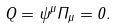<formula> <loc_0><loc_0><loc_500><loc_500>Q = \psi ^ { \mu } \Pi _ { \mu } = 0 .</formula> 